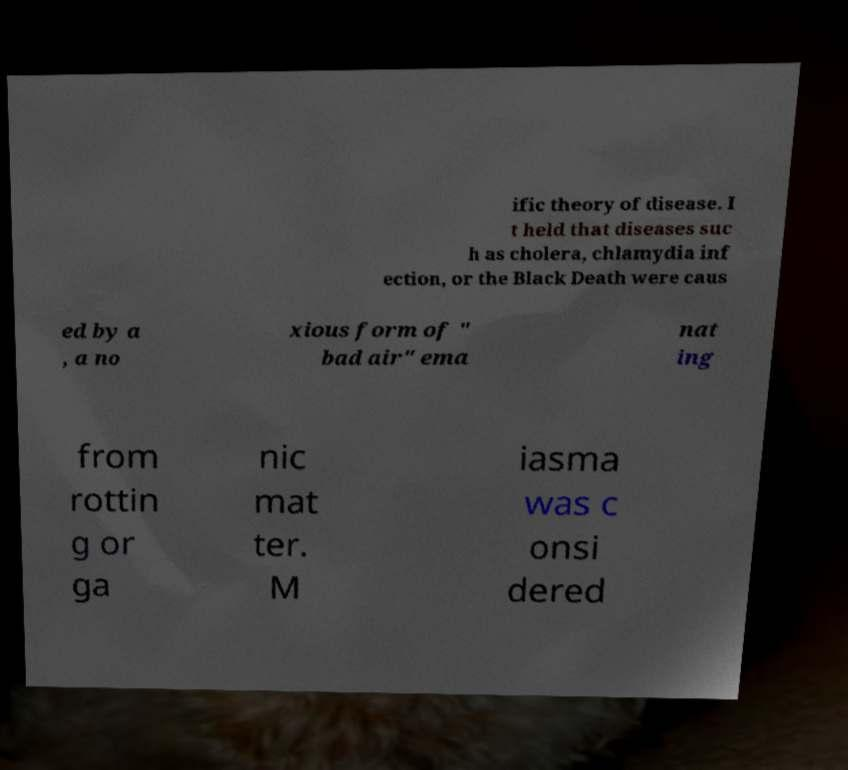Can you accurately transcribe the text from the provided image for me? ific theory of disease. I t held that diseases suc h as cholera, chlamydia inf ection, or the Black Death were caus ed by a , a no xious form of " bad air" ema nat ing from rottin g or ga nic mat ter. M iasma was c onsi dered 